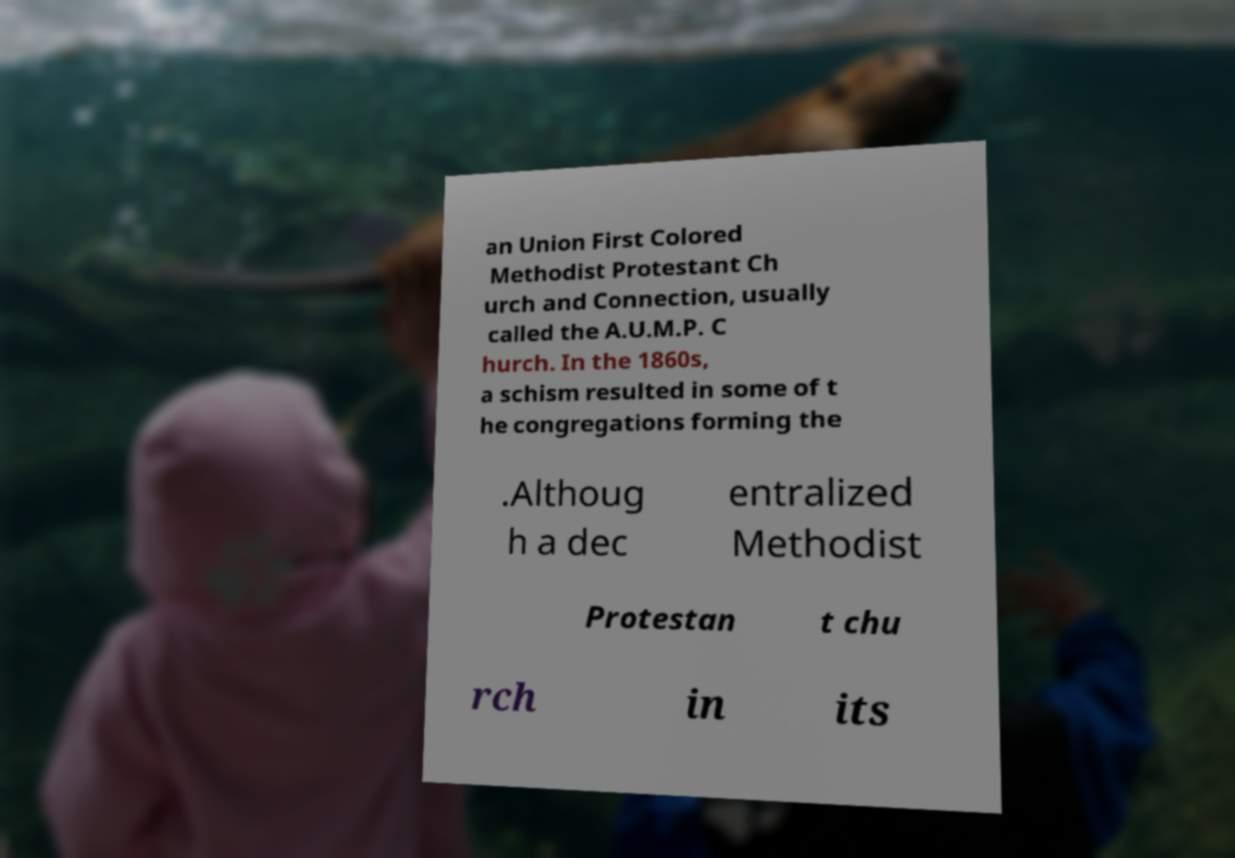There's text embedded in this image that I need extracted. Can you transcribe it verbatim? an Union First Colored Methodist Protestant Ch urch and Connection, usually called the A.U.M.P. C hurch. In the 1860s, a schism resulted in some of t he congregations forming the .Althoug h a dec entralized Methodist Protestan t chu rch in its 